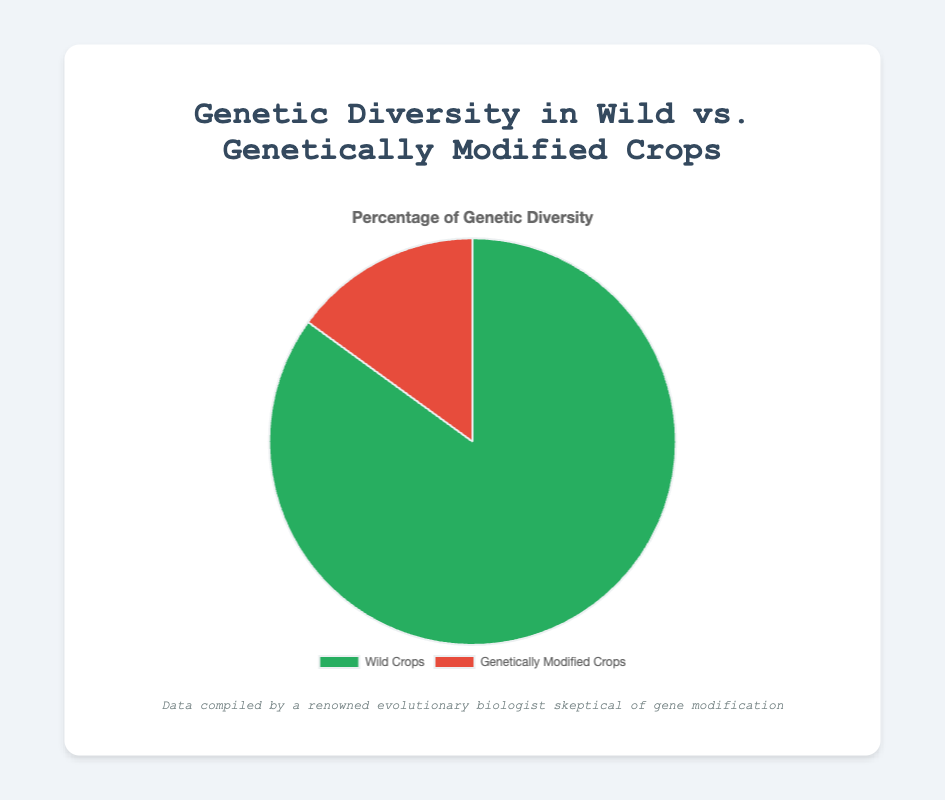How much higher is the genetic diversity percentage in wild crops compared to genetically modified crops? The wild crops have 85% genetic diversity, while genetically modified crops have 15%. To find the difference, subtract 15 from 85.
Answer: 70% What is the total percentage represented by the chart? The chart shows the genetic diversity in wild and genetically modified crops. The sum of these two percentages is 85% + 15%.
Answer: 100% Are wild crops more genetically diverse than genetically modified crops? Yes. According to the pie chart, wild crops have higher genetic diversity (85%) compared to genetically modified crops (15%).
Answer: Yes What percentage do genetically modified crops contribute to the overall genetic diversity? The pie chart shows that genetically modified crops contribute 15% to the overall genetic diversity.
Answer: 15% If you combine the genetic diversity percentages of wild and genetically modified crops, what would be the resulting percentage? Adding the genetic diversity percentages of wild crops and genetically modified crops gives 85% + 15%.
Answer: 100% Which type of crop has a smaller share of genetic diversity in the chart and by how much? Genetically modified crops have a smaller share of genetic diversity. The difference between wild crops (85%) and genetically modified crops (15%) is 85% - 15%.
Answer: Genetically modified crops by 70% What is the genetic diversity percentage of wild crops represented in green on the chart? The green section of the pie chart represents the genetic diversity percentage of wild crops, which is shown as 85%.
Answer: 85% How many varieties of GM Corn are there in North America according to the provided details? The data provided states that there are 3 varieties of GM Corn in North America.
Answer: 3 Where are wild soybeans predominantly found, according to the region listed? The region listed for wild soybeans in the provided details is East Asia.
Answer: East Asia Which type of crop is represented by the red section of the pie chart? The red section of the pie chart represents genetically modified crops.
Answer: Genetically modified crops 